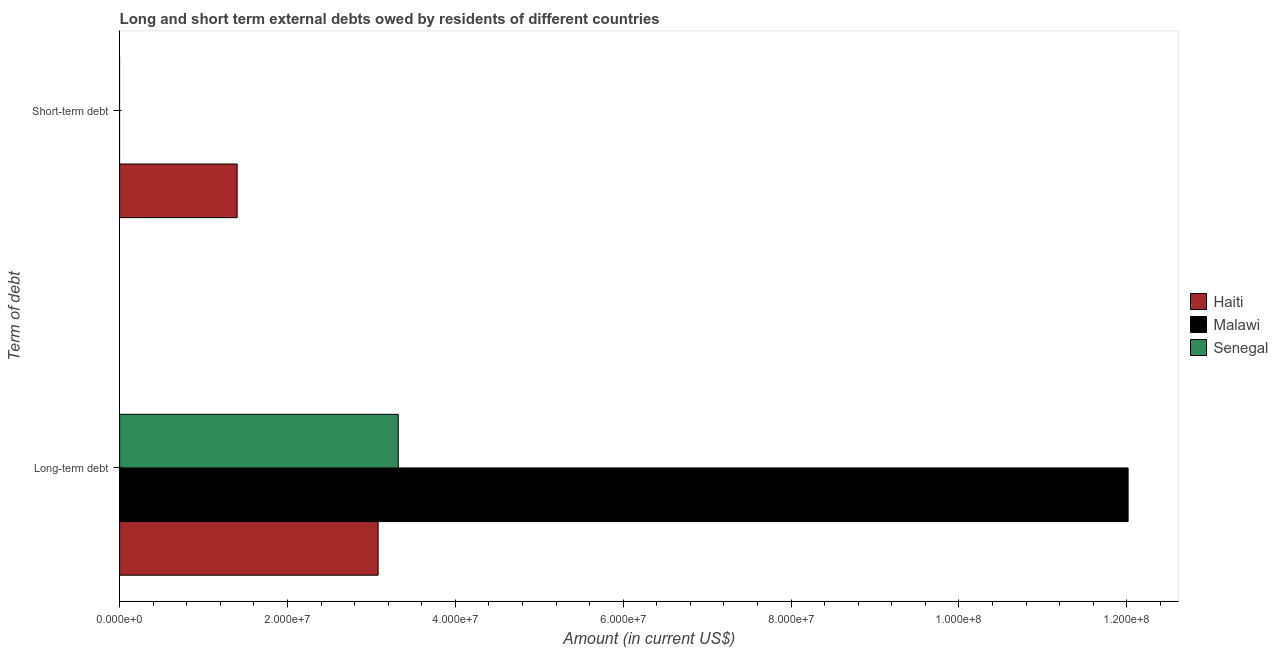How many different coloured bars are there?
Provide a short and direct response. 3. What is the label of the 2nd group of bars from the top?
Make the answer very short. Long-term debt. What is the long-term debts owed by residents in Senegal?
Provide a short and direct response. 3.32e+07. Across all countries, what is the maximum long-term debts owed by residents?
Keep it short and to the point. 1.20e+08. Across all countries, what is the minimum long-term debts owed by residents?
Provide a short and direct response. 3.08e+07. In which country was the long-term debts owed by residents maximum?
Make the answer very short. Malawi. What is the total short-term debts owed by residents in the graph?
Ensure brevity in your answer.  1.40e+07. What is the difference between the long-term debts owed by residents in Haiti and that in Senegal?
Ensure brevity in your answer.  -2.40e+06. What is the difference between the long-term debts owed by residents in Haiti and the short-term debts owed by residents in Malawi?
Provide a short and direct response. 3.08e+07. What is the average short-term debts owed by residents per country?
Ensure brevity in your answer.  4.67e+06. What is the difference between the short-term debts owed by residents and long-term debts owed by residents in Haiti?
Offer a terse response. -1.68e+07. What is the ratio of the long-term debts owed by residents in Senegal to that in Malawi?
Your response must be concise. 0.28. In how many countries, is the long-term debts owed by residents greater than the average long-term debts owed by residents taken over all countries?
Make the answer very short. 1. How many bars are there?
Offer a terse response. 4. Are all the bars in the graph horizontal?
Your response must be concise. Yes. How many countries are there in the graph?
Ensure brevity in your answer.  3. Are the values on the major ticks of X-axis written in scientific E-notation?
Give a very brief answer. Yes. Does the graph contain grids?
Your answer should be compact. No. Where does the legend appear in the graph?
Make the answer very short. Center right. What is the title of the graph?
Provide a succinct answer. Long and short term external debts owed by residents of different countries. What is the label or title of the Y-axis?
Provide a succinct answer. Term of debt. What is the Amount (in current US$) of Haiti in Long-term debt?
Your answer should be compact. 3.08e+07. What is the Amount (in current US$) of Malawi in Long-term debt?
Offer a very short reply. 1.20e+08. What is the Amount (in current US$) of Senegal in Long-term debt?
Make the answer very short. 3.32e+07. What is the Amount (in current US$) of Haiti in Short-term debt?
Your response must be concise. 1.40e+07. Across all Term of debt, what is the maximum Amount (in current US$) in Haiti?
Offer a terse response. 3.08e+07. Across all Term of debt, what is the maximum Amount (in current US$) in Malawi?
Your response must be concise. 1.20e+08. Across all Term of debt, what is the maximum Amount (in current US$) of Senegal?
Ensure brevity in your answer.  3.32e+07. Across all Term of debt, what is the minimum Amount (in current US$) in Haiti?
Make the answer very short. 1.40e+07. Across all Term of debt, what is the minimum Amount (in current US$) in Malawi?
Give a very brief answer. 0. Across all Term of debt, what is the minimum Amount (in current US$) of Senegal?
Offer a very short reply. 0. What is the total Amount (in current US$) of Haiti in the graph?
Provide a succinct answer. 4.48e+07. What is the total Amount (in current US$) of Malawi in the graph?
Give a very brief answer. 1.20e+08. What is the total Amount (in current US$) in Senegal in the graph?
Give a very brief answer. 3.32e+07. What is the difference between the Amount (in current US$) of Haiti in Long-term debt and that in Short-term debt?
Provide a succinct answer. 1.68e+07. What is the average Amount (in current US$) in Haiti per Term of debt?
Your answer should be compact. 2.24e+07. What is the average Amount (in current US$) of Malawi per Term of debt?
Your answer should be compact. 6.01e+07. What is the average Amount (in current US$) in Senegal per Term of debt?
Your answer should be very brief. 1.66e+07. What is the difference between the Amount (in current US$) in Haiti and Amount (in current US$) in Malawi in Long-term debt?
Give a very brief answer. -8.94e+07. What is the difference between the Amount (in current US$) in Haiti and Amount (in current US$) in Senegal in Long-term debt?
Provide a succinct answer. -2.40e+06. What is the difference between the Amount (in current US$) of Malawi and Amount (in current US$) of Senegal in Long-term debt?
Make the answer very short. 8.70e+07. What is the ratio of the Amount (in current US$) of Haiti in Long-term debt to that in Short-term debt?
Offer a very short reply. 2.2. What is the difference between the highest and the second highest Amount (in current US$) in Haiti?
Provide a succinct answer. 1.68e+07. What is the difference between the highest and the lowest Amount (in current US$) in Haiti?
Provide a succinct answer. 1.68e+07. What is the difference between the highest and the lowest Amount (in current US$) of Malawi?
Your response must be concise. 1.20e+08. What is the difference between the highest and the lowest Amount (in current US$) in Senegal?
Make the answer very short. 3.32e+07. 